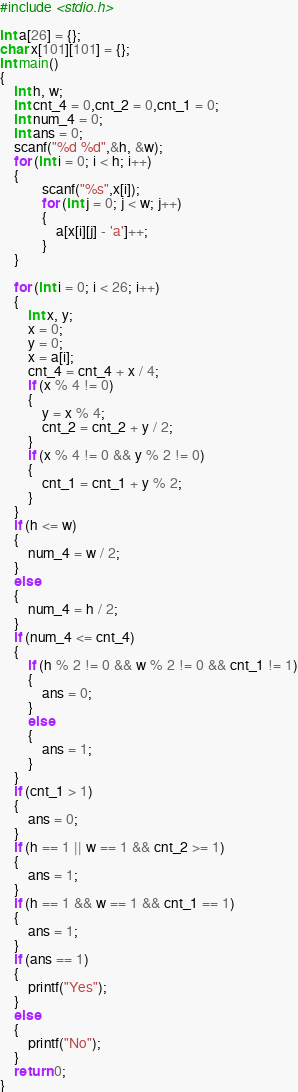<code> <loc_0><loc_0><loc_500><loc_500><_C_>#include <stdio.h>

int a[26] = {};
char x[101][101] = {};
int main()
{
	int h, w;
	int cnt_4 = 0,cnt_2 = 0,cnt_1 = 0;
	int num_4 = 0;
	int ans = 0;
	scanf("%d %d",&h, &w);
	for (int i = 0; i < h; i++)
	{
			scanf("%s",x[i]);
			for (int j = 0; j < w; j++)
			{
				a[x[i][j] - 'a']++;
			}
	}

	for (int i = 0; i < 26; i++)
	{
		int x, y;
		x = 0;
		y = 0;
		x = a[i];
		cnt_4 = cnt_4 + x / 4;
		if (x % 4 != 0)
		{
			y = x % 4;
			cnt_2 = cnt_2 + y / 2;
		}
		if (x % 4 != 0 && y % 2 != 0)
		{
			cnt_1 = cnt_1 + y % 2;
		}
	}
	if (h <= w)
	{
		num_4 = w / 2;
	}
	else
	{
		num_4 = h / 2;
	}
	if (num_4 <= cnt_4)
	{
		if (h % 2 != 0 && w % 2 != 0 && cnt_1 != 1)
		{
			ans = 0;
		}
		else
		{
			ans = 1;
		}
	}
	if (cnt_1 > 1)
	{
		ans = 0;
	}
	if (h == 1 || w == 1 && cnt_2 >= 1)
	{
		ans = 1;
	}
	if (h == 1 && w == 1 && cnt_1 == 1)
	{
		ans = 1;
	}
	if (ans == 1)
	{
		printf("Yes");
	}
	else
	{
		printf("No");
	}
	return 0;
}</code> 